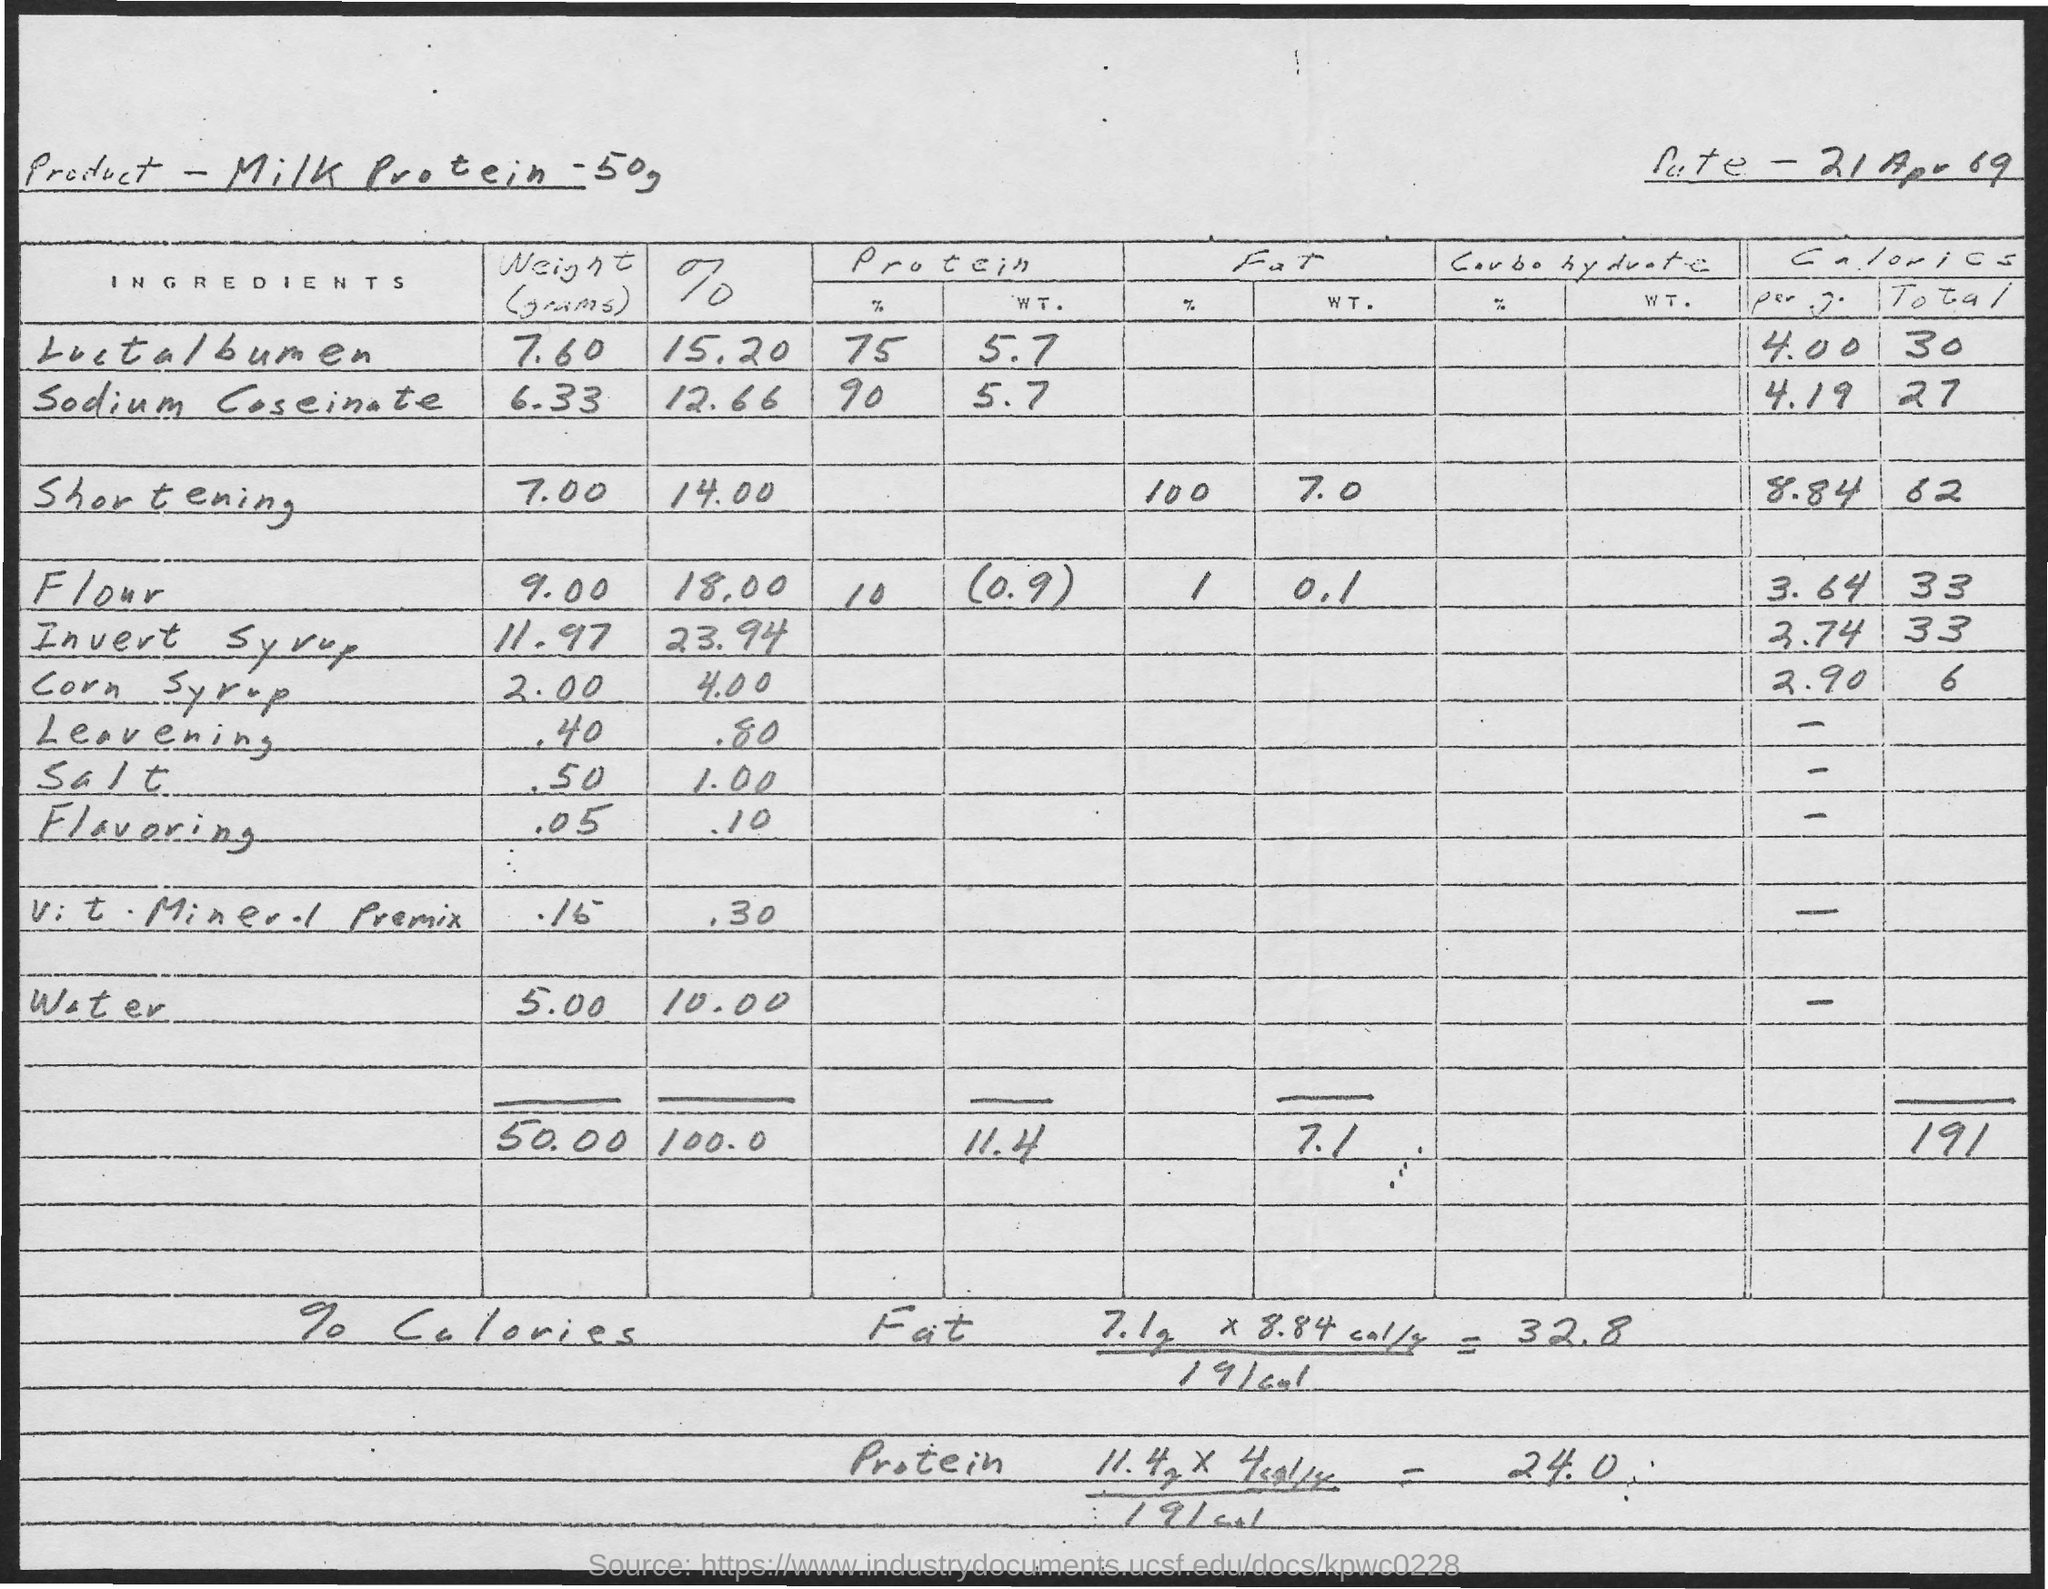List a handful of essential elements in this visual. The weight of corn syrup is 2.00.. The product contains 100% salt. This product is a milk protein supplement containing 50 grams, designed to provide nutritional support for those looking to meet their daily protein needs. 